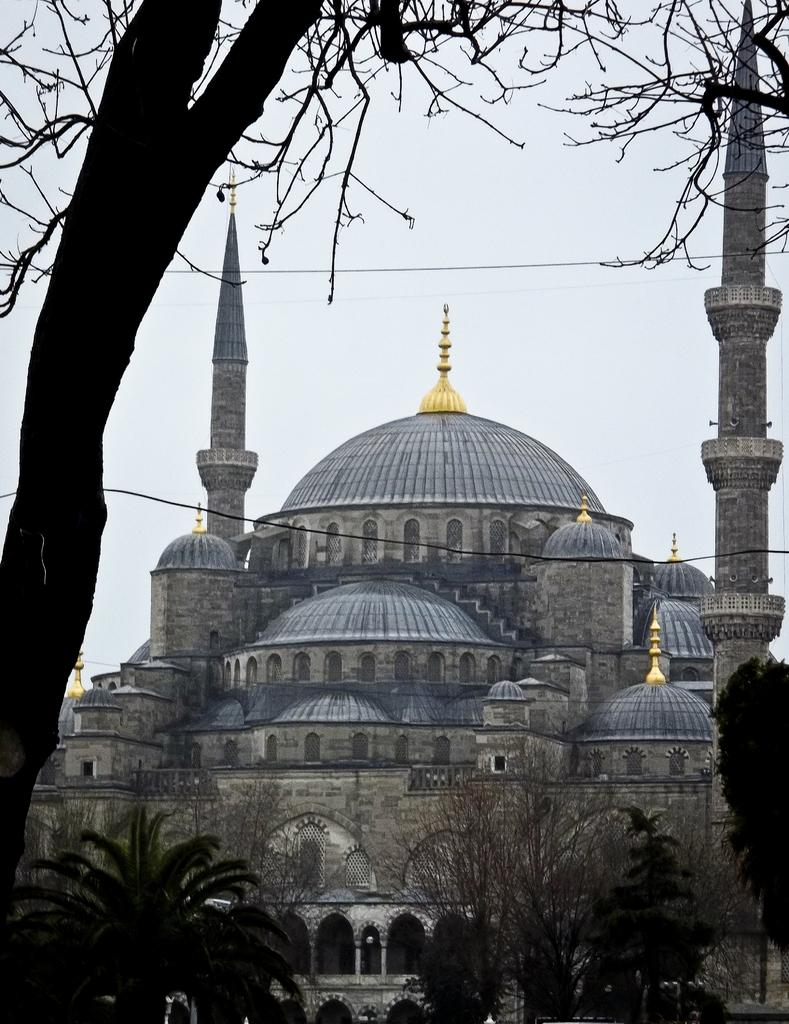What type of structures are present in the image? There are buildings in the image. What can be seen around the buildings? There are trees around the buildings. What other types of vegetation are visible in the image? There are plants in the image. What type of activity is the dad participating in with the dime in the image? There is no dad or dime present in the image, so it is not possible to answer that question. 